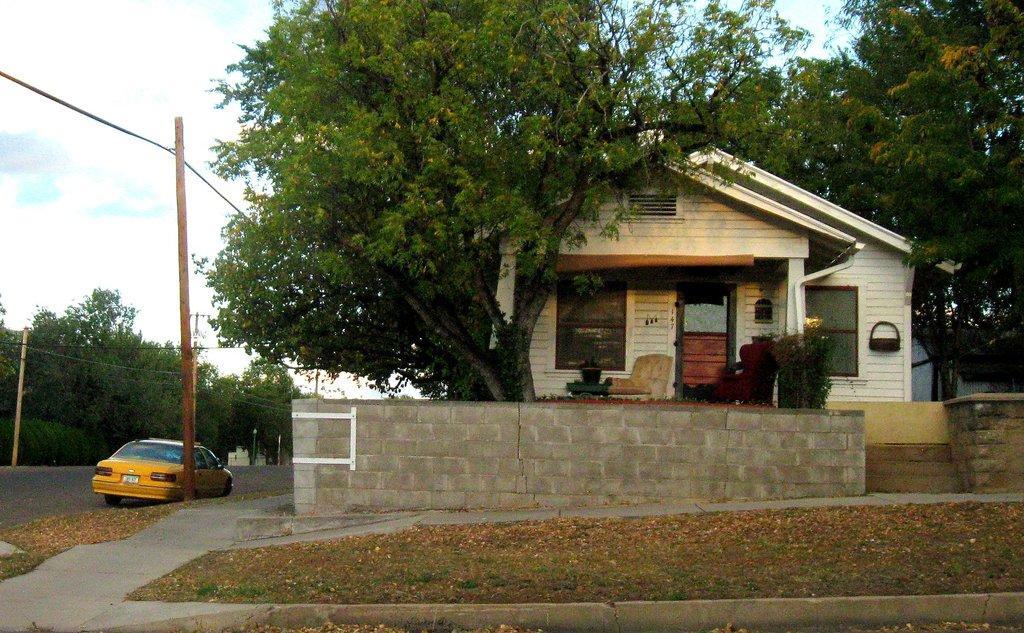Please provide a concise description of this image. This image is taken outdoors. At the top of the image there is the sky with clouds. At the bottom of the image there is a ground with grass on it and there are many dry leaves on the ground. There is a road. On the left side of the image there are many trees and there are a few poles and a car is parked on the road. On the right side of the image there is a house with walls, windows, a roof and a roof. There is a couch and there are a few plants in the pots. There are a few trees with leaves, stems and branches. 